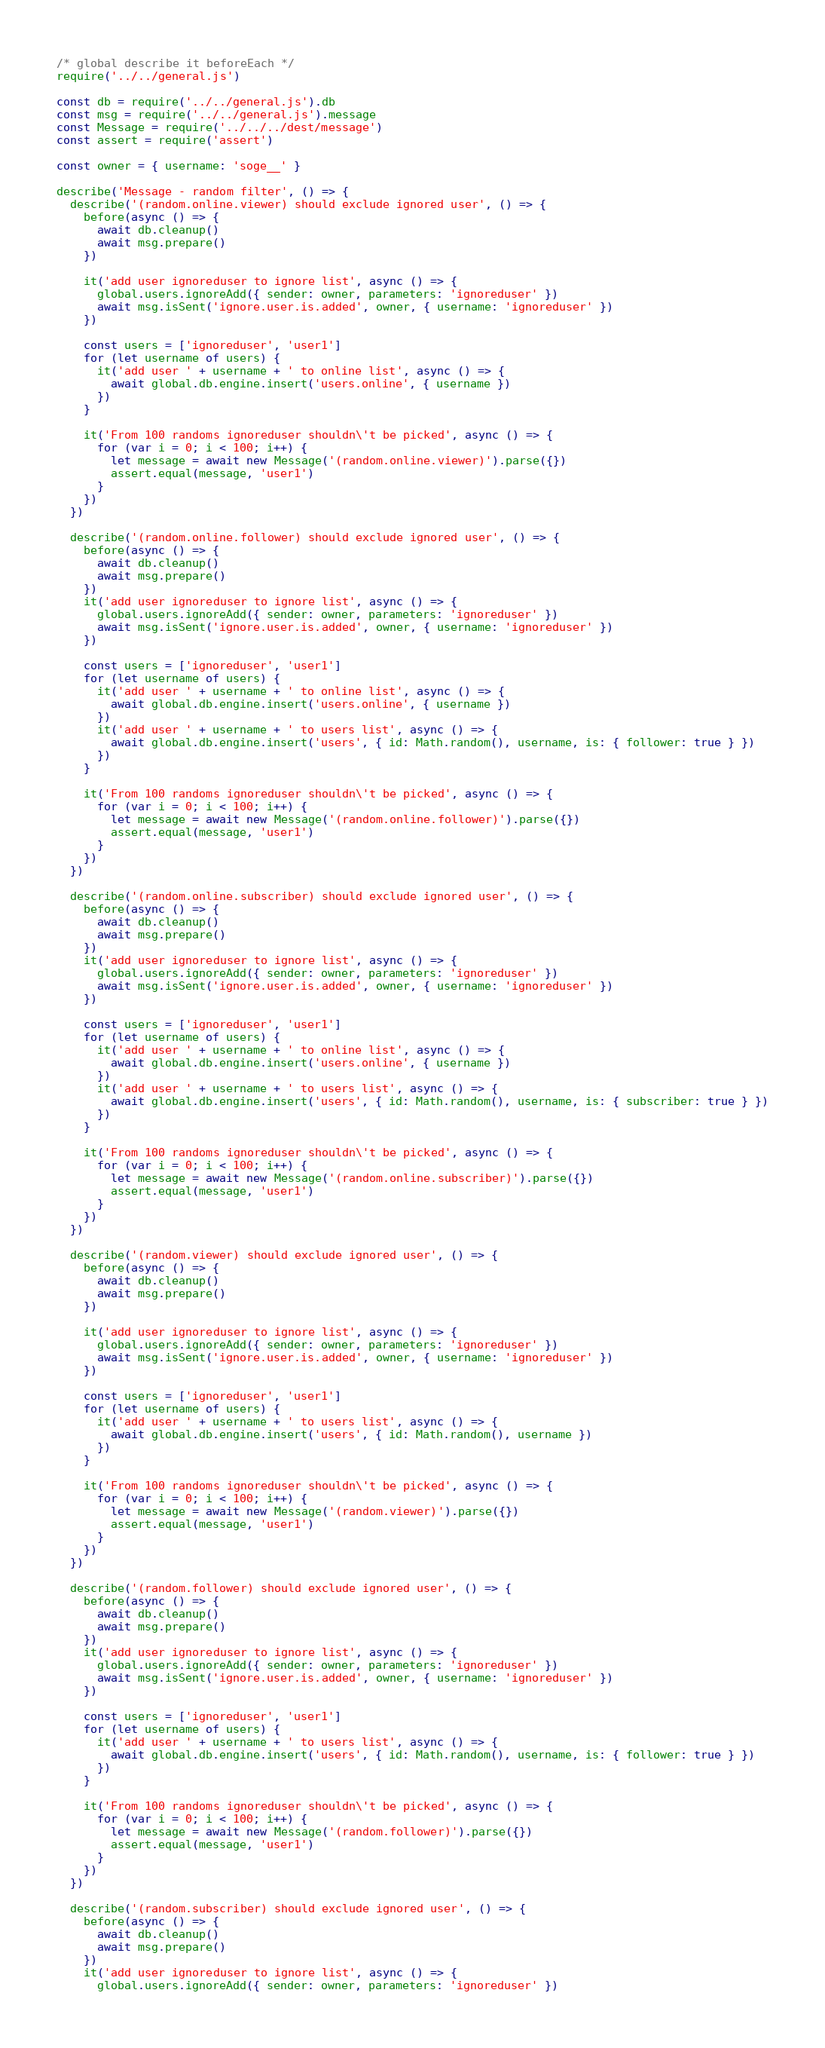<code> <loc_0><loc_0><loc_500><loc_500><_JavaScript_>/* global describe it beforeEach */
require('../../general.js')

const db = require('../../general.js').db
const msg = require('../../general.js').message
const Message = require('../../../dest/message')
const assert = require('assert')

const owner = { username: 'soge__' }

describe('Message - random filter', () => {
  describe('(random.online.viewer) should exclude ignored user', () => {
    before(async () => {
      await db.cleanup()
      await msg.prepare()
    })

    it('add user ignoreduser to ignore list', async () => {
      global.users.ignoreAdd({ sender: owner, parameters: 'ignoreduser' })
      await msg.isSent('ignore.user.is.added', owner, { username: 'ignoreduser' })
    })

    const users = ['ignoreduser', 'user1']
    for (let username of users) {
      it('add user ' + username + ' to online list', async () => {
        await global.db.engine.insert('users.online', { username })
      })
    }

    it('From 100 randoms ignoreduser shouldn\'t be picked', async () => {
      for (var i = 0; i < 100; i++) {
        let message = await new Message('(random.online.viewer)').parse({})
        assert.equal(message, 'user1')
      }
    })
  })

  describe('(random.online.follower) should exclude ignored user', () => {
    before(async () => {
      await db.cleanup()
      await msg.prepare()
    })
    it('add user ignoreduser to ignore list', async () => {
      global.users.ignoreAdd({ sender: owner, parameters: 'ignoreduser' })
      await msg.isSent('ignore.user.is.added', owner, { username: 'ignoreduser' })
    })

    const users = ['ignoreduser', 'user1']
    for (let username of users) {
      it('add user ' + username + ' to online list', async () => {
        await global.db.engine.insert('users.online', { username })
      })
      it('add user ' + username + ' to users list', async () => {
        await global.db.engine.insert('users', { id: Math.random(), username, is: { follower: true } })
      })
    }

    it('From 100 randoms ignoreduser shouldn\'t be picked', async () => {
      for (var i = 0; i < 100; i++) {
        let message = await new Message('(random.online.follower)').parse({})
        assert.equal(message, 'user1')
      }
    })
  })

  describe('(random.online.subscriber) should exclude ignored user', () => {
    before(async () => {
      await db.cleanup()
      await msg.prepare()
    })
    it('add user ignoreduser to ignore list', async () => {
      global.users.ignoreAdd({ sender: owner, parameters: 'ignoreduser' })
      await msg.isSent('ignore.user.is.added', owner, { username: 'ignoreduser' })
    })

    const users = ['ignoreduser', 'user1']
    for (let username of users) {
      it('add user ' + username + ' to online list', async () => {
        await global.db.engine.insert('users.online', { username })
      })
      it('add user ' + username + ' to users list', async () => {
        await global.db.engine.insert('users', { id: Math.random(), username, is: { subscriber: true } })
      })
    }

    it('From 100 randoms ignoreduser shouldn\'t be picked', async () => {
      for (var i = 0; i < 100; i++) {
        let message = await new Message('(random.online.subscriber)').parse({})
        assert.equal(message, 'user1')
      }
    })
  })

  describe('(random.viewer) should exclude ignored user', () => {
    before(async () => {
      await db.cleanup()
      await msg.prepare()
    })

    it('add user ignoreduser to ignore list', async () => {
      global.users.ignoreAdd({ sender: owner, parameters: 'ignoreduser' })
      await msg.isSent('ignore.user.is.added', owner, { username: 'ignoreduser' })
    })

    const users = ['ignoreduser', 'user1']
    for (let username of users) {
      it('add user ' + username + ' to users list', async () => {
        await global.db.engine.insert('users', { id: Math.random(), username })
      })
    }

    it('From 100 randoms ignoreduser shouldn\'t be picked', async () => {
      for (var i = 0; i < 100; i++) {
        let message = await new Message('(random.viewer)').parse({})
        assert.equal(message, 'user1')
      }
    })
  })

  describe('(random.follower) should exclude ignored user', () => {
    before(async () => {
      await db.cleanup()
      await msg.prepare()
    })
    it('add user ignoreduser to ignore list', async () => {
      global.users.ignoreAdd({ sender: owner, parameters: 'ignoreduser' })
      await msg.isSent('ignore.user.is.added', owner, { username: 'ignoreduser' })
    })

    const users = ['ignoreduser', 'user1']
    for (let username of users) {
      it('add user ' + username + ' to users list', async () => {
        await global.db.engine.insert('users', { id: Math.random(), username, is: { follower: true } })
      })
    }

    it('From 100 randoms ignoreduser shouldn\'t be picked', async () => {
      for (var i = 0; i < 100; i++) {
        let message = await new Message('(random.follower)').parse({})
        assert.equal(message, 'user1')
      }
    })
  })

  describe('(random.subscriber) should exclude ignored user', () => {
    before(async () => {
      await db.cleanup()
      await msg.prepare()
    })
    it('add user ignoreduser to ignore list', async () => {
      global.users.ignoreAdd({ sender: owner, parameters: 'ignoreduser' })</code> 